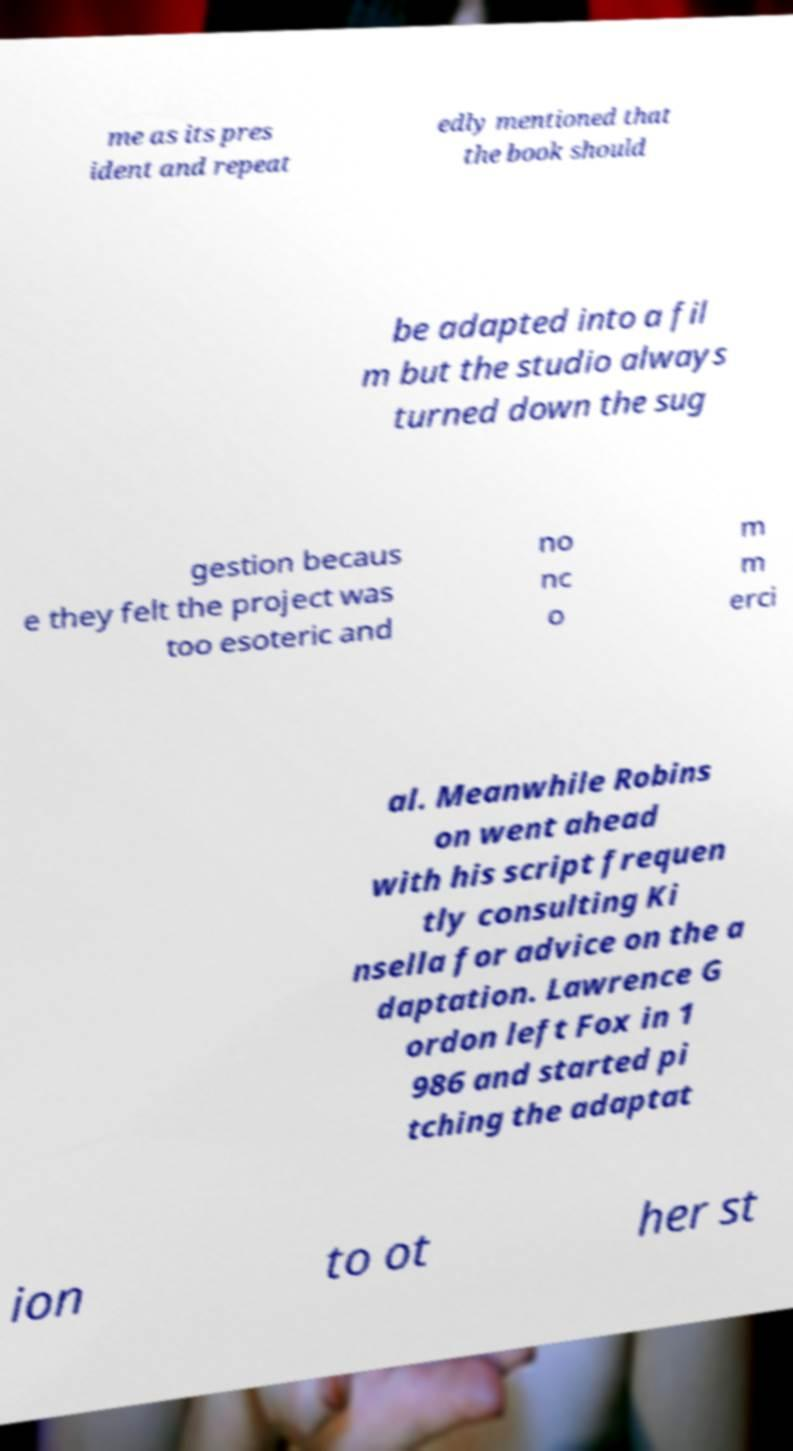There's text embedded in this image that I need extracted. Can you transcribe it verbatim? me as its pres ident and repeat edly mentioned that the book should be adapted into a fil m but the studio always turned down the sug gestion becaus e they felt the project was too esoteric and no nc o m m erci al. Meanwhile Robins on went ahead with his script frequen tly consulting Ki nsella for advice on the a daptation. Lawrence G ordon left Fox in 1 986 and started pi tching the adaptat ion to ot her st 